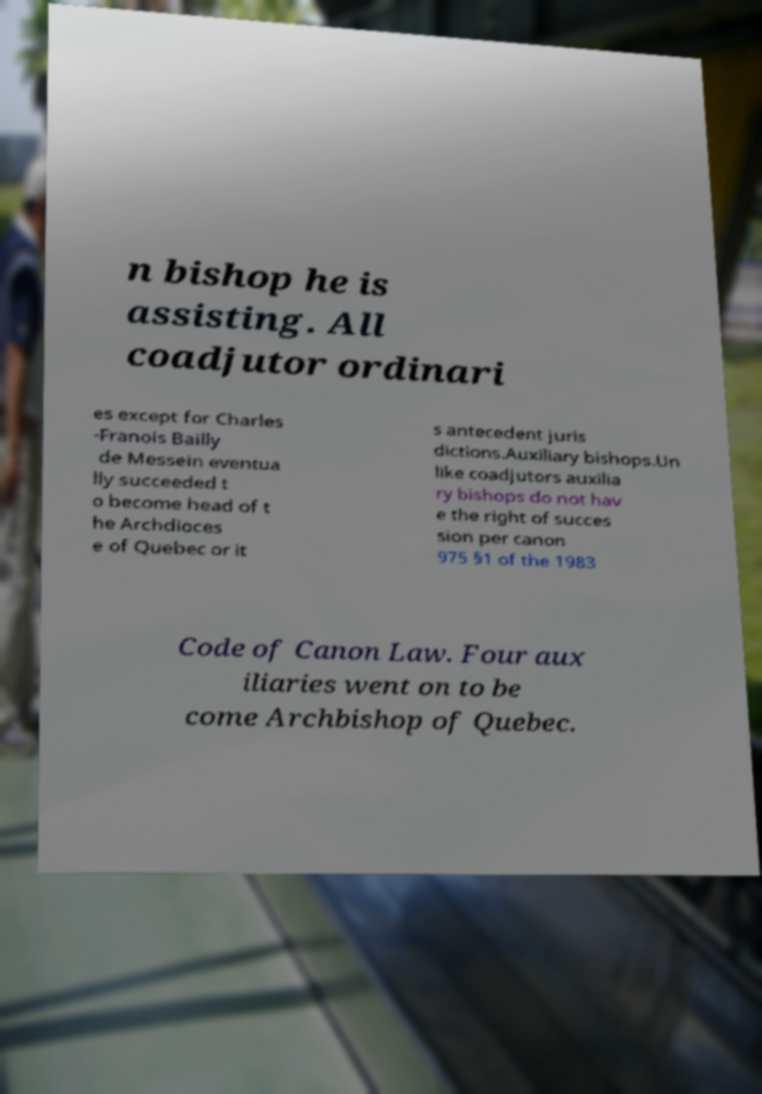Could you assist in decoding the text presented in this image and type it out clearly? n bishop he is assisting. All coadjutor ordinari es except for Charles -Franois Bailly de Messein eventua lly succeeded t o become head of t he Archdioces e of Quebec or it s antecedent juris dictions.Auxiliary bishops.Un like coadjutors auxilia ry bishops do not hav e the right of succes sion per canon 975 §1 of the 1983 Code of Canon Law. Four aux iliaries went on to be come Archbishop of Quebec. 